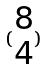Convert formula to latex. <formula><loc_0><loc_0><loc_500><loc_500>( \begin{matrix} 8 \\ 4 \end{matrix} )</formula> 